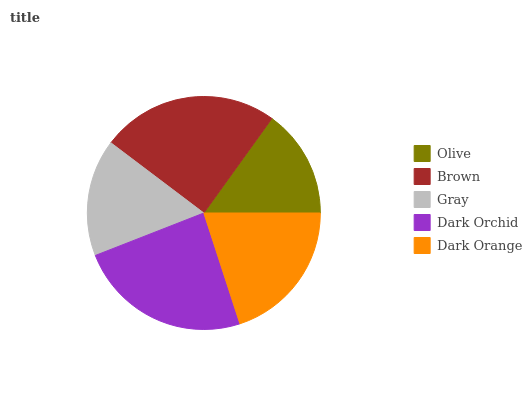Is Olive the minimum?
Answer yes or no. Yes. Is Brown the maximum?
Answer yes or no. Yes. Is Gray the minimum?
Answer yes or no. No. Is Gray the maximum?
Answer yes or no. No. Is Brown greater than Gray?
Answer yes or no. Yes. Is Gray less than Brown?
Answer yes or no. Yes. Is Gray greater than Brown?
Answer yes or no. No. Is Brown less than Gray?
Answer yes or no. No. Is Dark Orange the high median?
Answer yes or no. Yes. Is Dark Orange the low median?
Answer yes or no. Yes. Is Olive the high median?
Answer yes or no. No. Is Brown the low median?
Answer yes or no. No. 